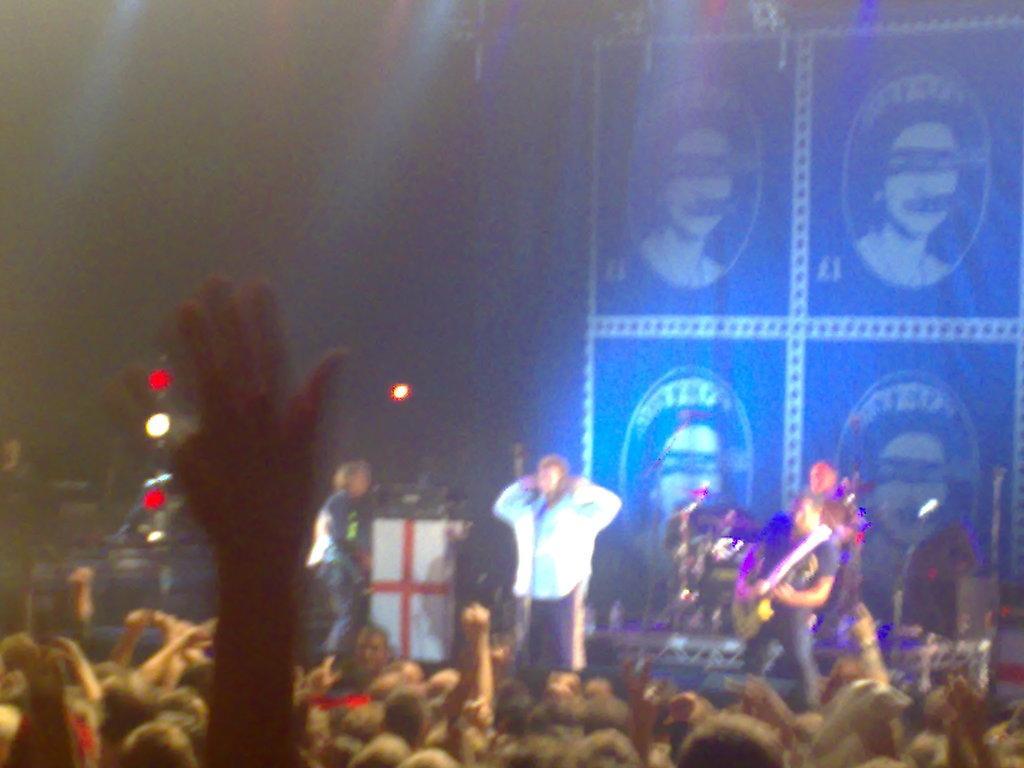Describe this image in one or two sentences. In this image we can see some people standing on the stage. In that a man is holding a guitar. we can also see a group of people. On the backside we can see a banner. 